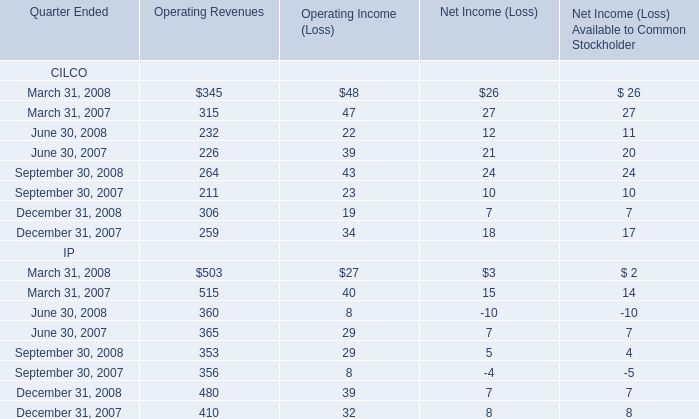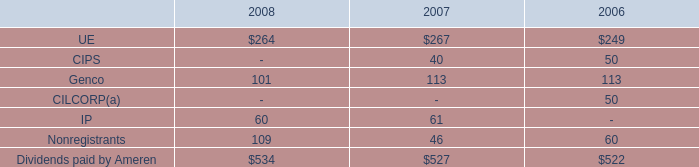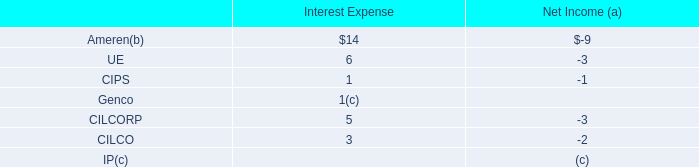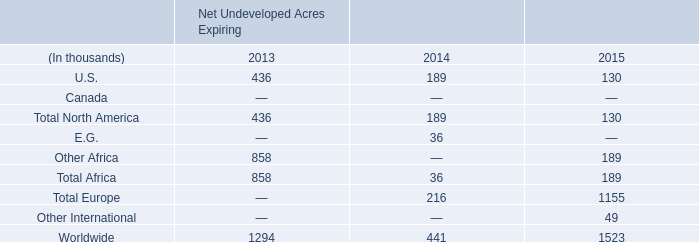based on synthetic crude oil sales volumes for 2012 , what are the deemed mbbld due to royalty production? 
Computations: (47 - 41)
Answer: 6.0. 